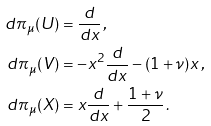<formula> <loc_0><loc_0><loc_500><loc_500>d \pi _ { \mu } ( U ) & = \frac { d } { d x } \, , \\ d \pi _ { \mu } ( V ) & = - x ^ { 2 } \frac { d } { d x } - ( 1 + \nu ) x \, , \\ d \pi _ { \mu } ( X ) & = x \frac { d } { d x } + \frac { 1 + \nu } { 2 } \, .</formula> 